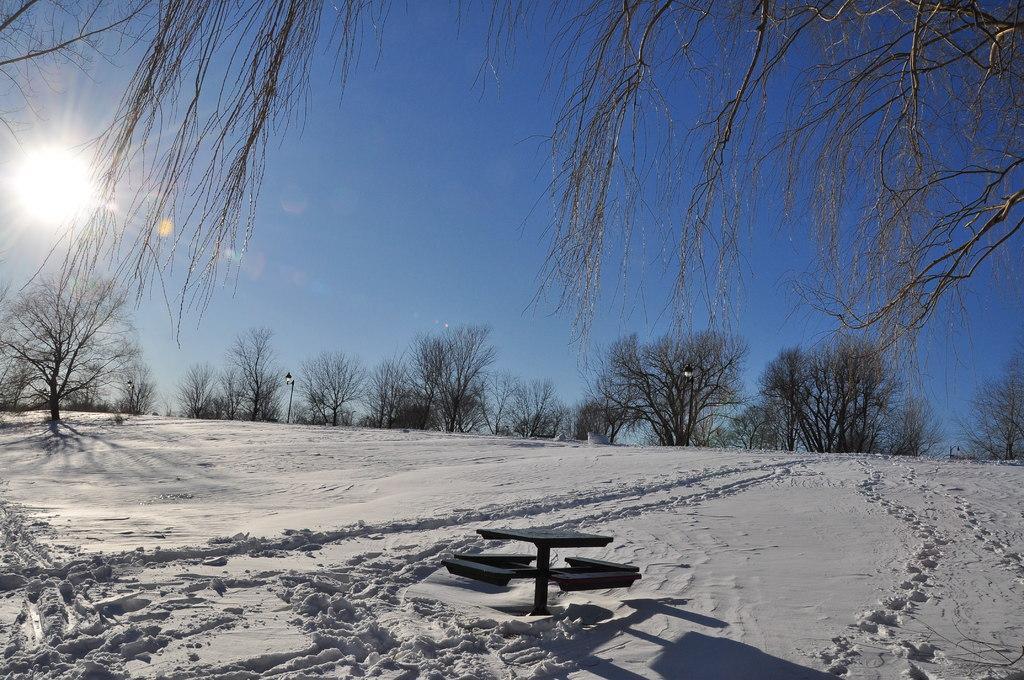Describe this image in one or two sentences. In this image I can see snow in white color. I can also see a bench, background I can see dried trees, sky in blue color. 